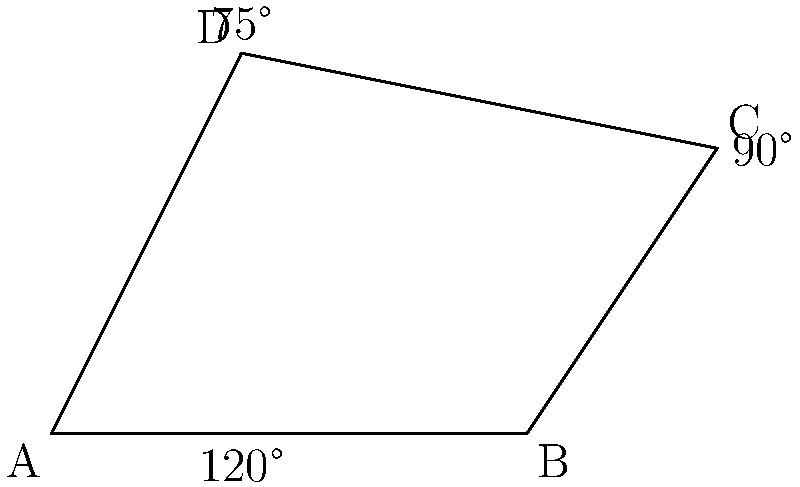Willie's oddly-shaped garden plot is represented by the quadrilateral ABCD. Given that angle ABC is 120°, angle BCD is 90°, and angle CDA is 75°, what is the measure of angle DAB? To find the measure of angle DAB, we can follow these steps:

1. Recall that the sum of interior angles in any quadrilateral is 360°.

2. Let's denote the measure of angle DAB as $x$.

3. We can write an equation based on the given information:
   $x + 120° + 90° + 75° = 360°$

4. Simplify the left side of the equation:
   $x + 285° = 360°$

5. Subtract 285° from both sides:
   $x = 360° - 285°$

6. Calculate the result:
   $x = 75°$

Therefore, the measure of angle DAB is 75°.
Answer: 75° 